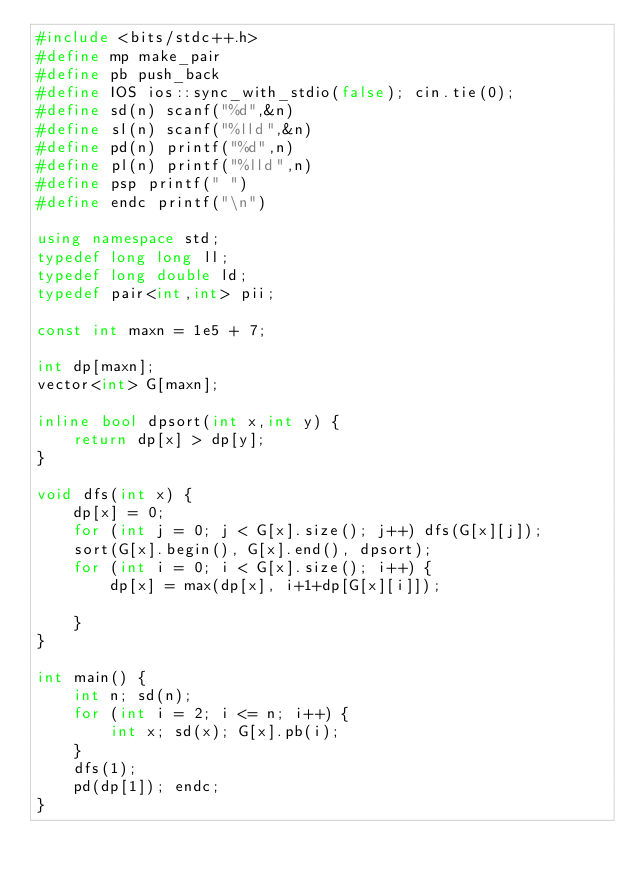<code> <loc_0><loc_0><loc_500><loc_500><_C++_>#include <bits/stdc++.h>
#define mp make_pair
#define pb push_back
#define IOS ios::sync_with_stdio(false); cin.tie(0);
#define sd(n) scanf("%d",&n)
#define sl(n) scanf("%lld",&n)
#define pd(n) printf("%d",n)
#define pl(n) printf("%lld",n)
#define psp printf(" ")
#define endc printf("\n")

using namespace std;
typedef long long ll;
typedef long double ld;
typedef pair<int,int> pii;

const int maxn = 1e5 + 7; 

int dp[maxn];
vector<int> G[maxn];

inline bool dpsort(int x,int y) {
	return dp[x] > dp[y];
}

void dfs(int x) {
	dp[x] = 0;
	for (int j = 0; j < G[x].size(); j++) dfs(G[x][j]);
	sort(G[x].begin(), G[x].end(), dpsort);
	for (int i = 0; i < G[x].size(); i++) {
		dp[x] = max(dp[x], i+1+dp[G[x][i]]);
		
	}
}

int main() {
	int n; sd(n);
	for (int i = 2; i <= n; i++) {
		int x; sd(x); G[x].pb(i);
	}
	dfs(1);
	pd(dp[1]); endc;
}
</code> 